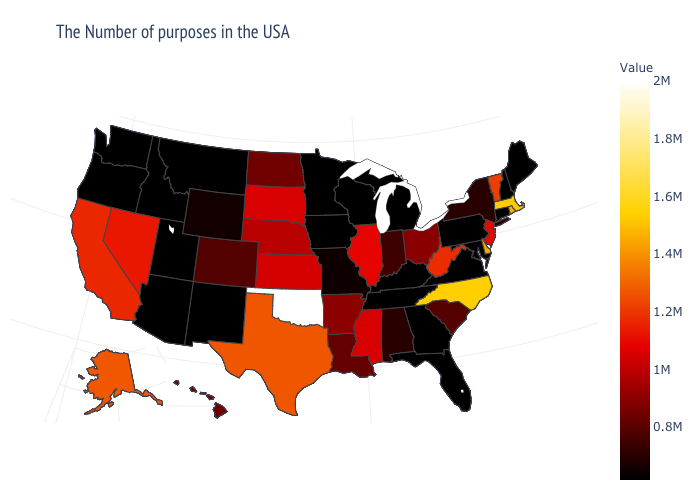Does Idaho have the highest value in the USA?
Quick response, please. No. Is the legend a continuous bar?
Quick response, please. Yes. Is the legend a continuous bar?
Write a very short answer. Yes. Does Illinois have the highest value in the MidWest?
Be succinct. Yes. Among the states that border Oklahoma , which have the lowest value?
Answer briefly. New Mexico. Is the legend a continuous bar?
Be succinct. Yes. Does Michigan have the lowest value in the USA?
Short answer required. Yes. Does the map have missing data?
Quick response, please. No. 